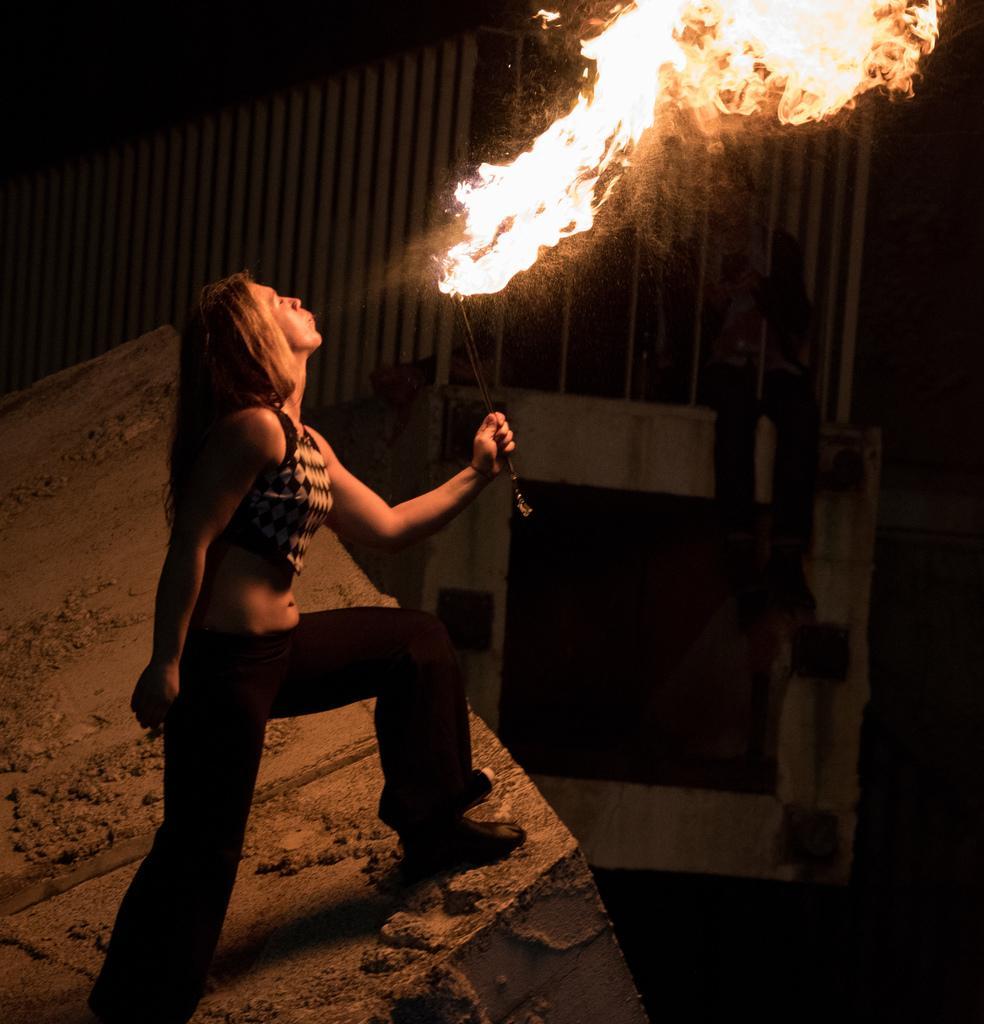Could you give a brief overview of what you see in this image? In this image we can see a woman standing on the floor and blowing fire. In the background we can see another person. 